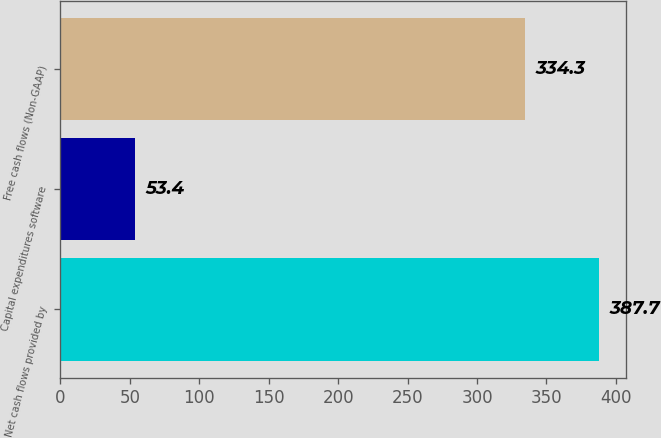Convert chart to OTSL. <chart><loc_0><loc_0><loc_500><loc_500><bar_chart><fcel>Net cash flows provided by<fcel>Capital expenditures software<fcel>Free cash flows (Non-GAAP)<nl><fcel>387.7<fcel>53.4<fcel>334.3<nl></chart> 